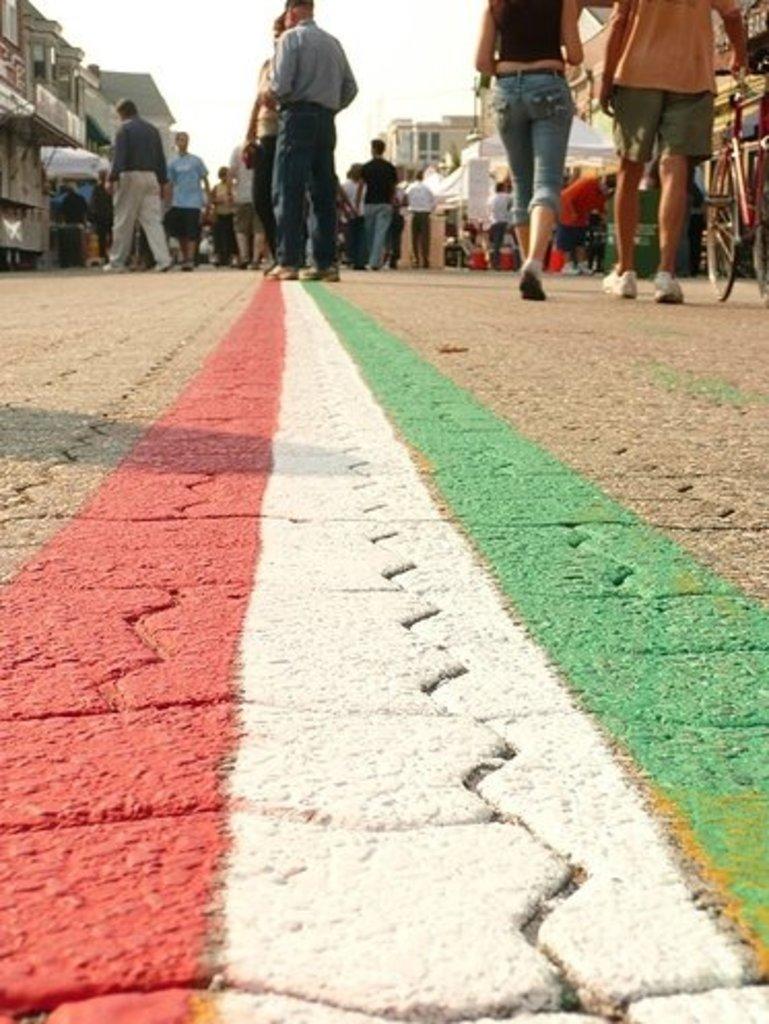Please provide a concise description of this image. In this image in the center there are some people who are walking on the road, at the bottom there is a road. On the road there is some painting and in the background there are some houses and buildings, on the right side there is one vehicle. 